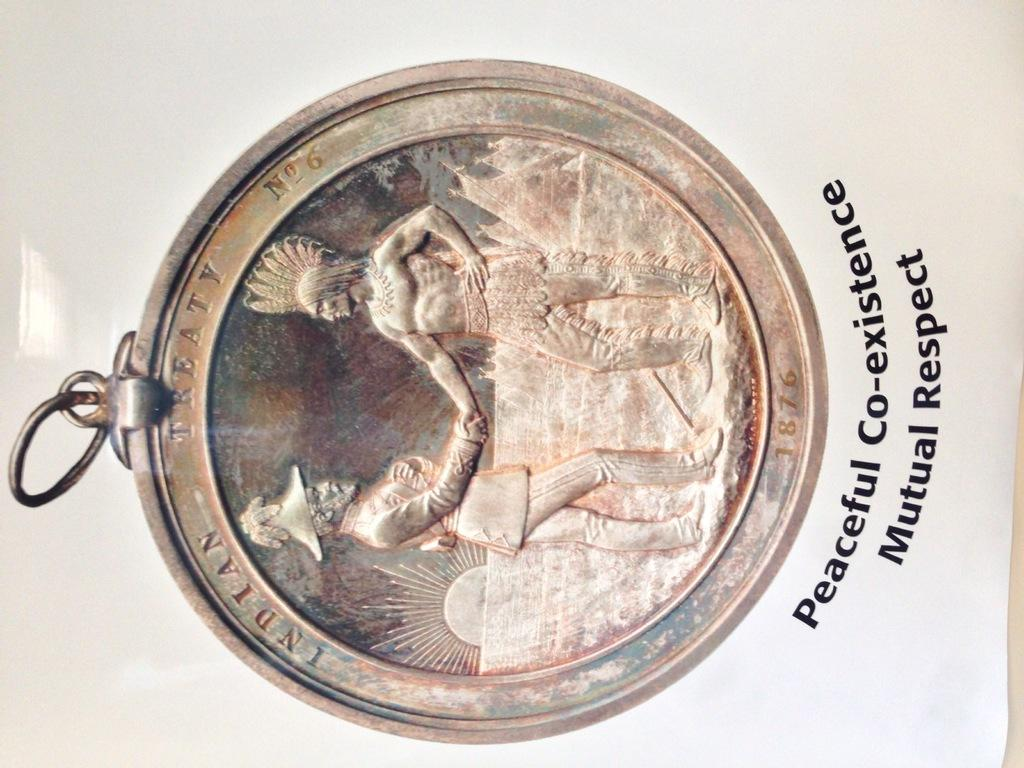<image>
Describe the image concisely. Copper coin that says the word Indian on the top. 